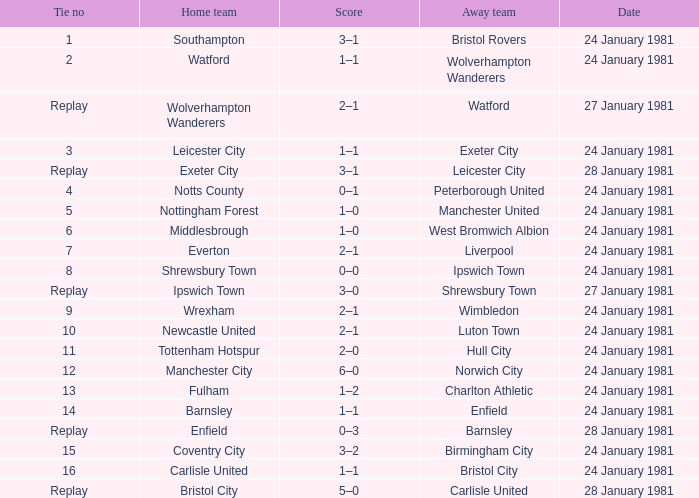Who is the home team with Liverpool as the away? Everton. 